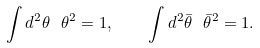Convert formula to latex. <formula><loc_0><loc_0><loc_500><loc_500>\int d ^ { 2 } \theta \ \theta ^ { 2 } = 1 , \quad \int d ^ { 2 } { \bar { \theta } } \ { \bar { \theta } } ^ { 2 } = 1 .</formula> 